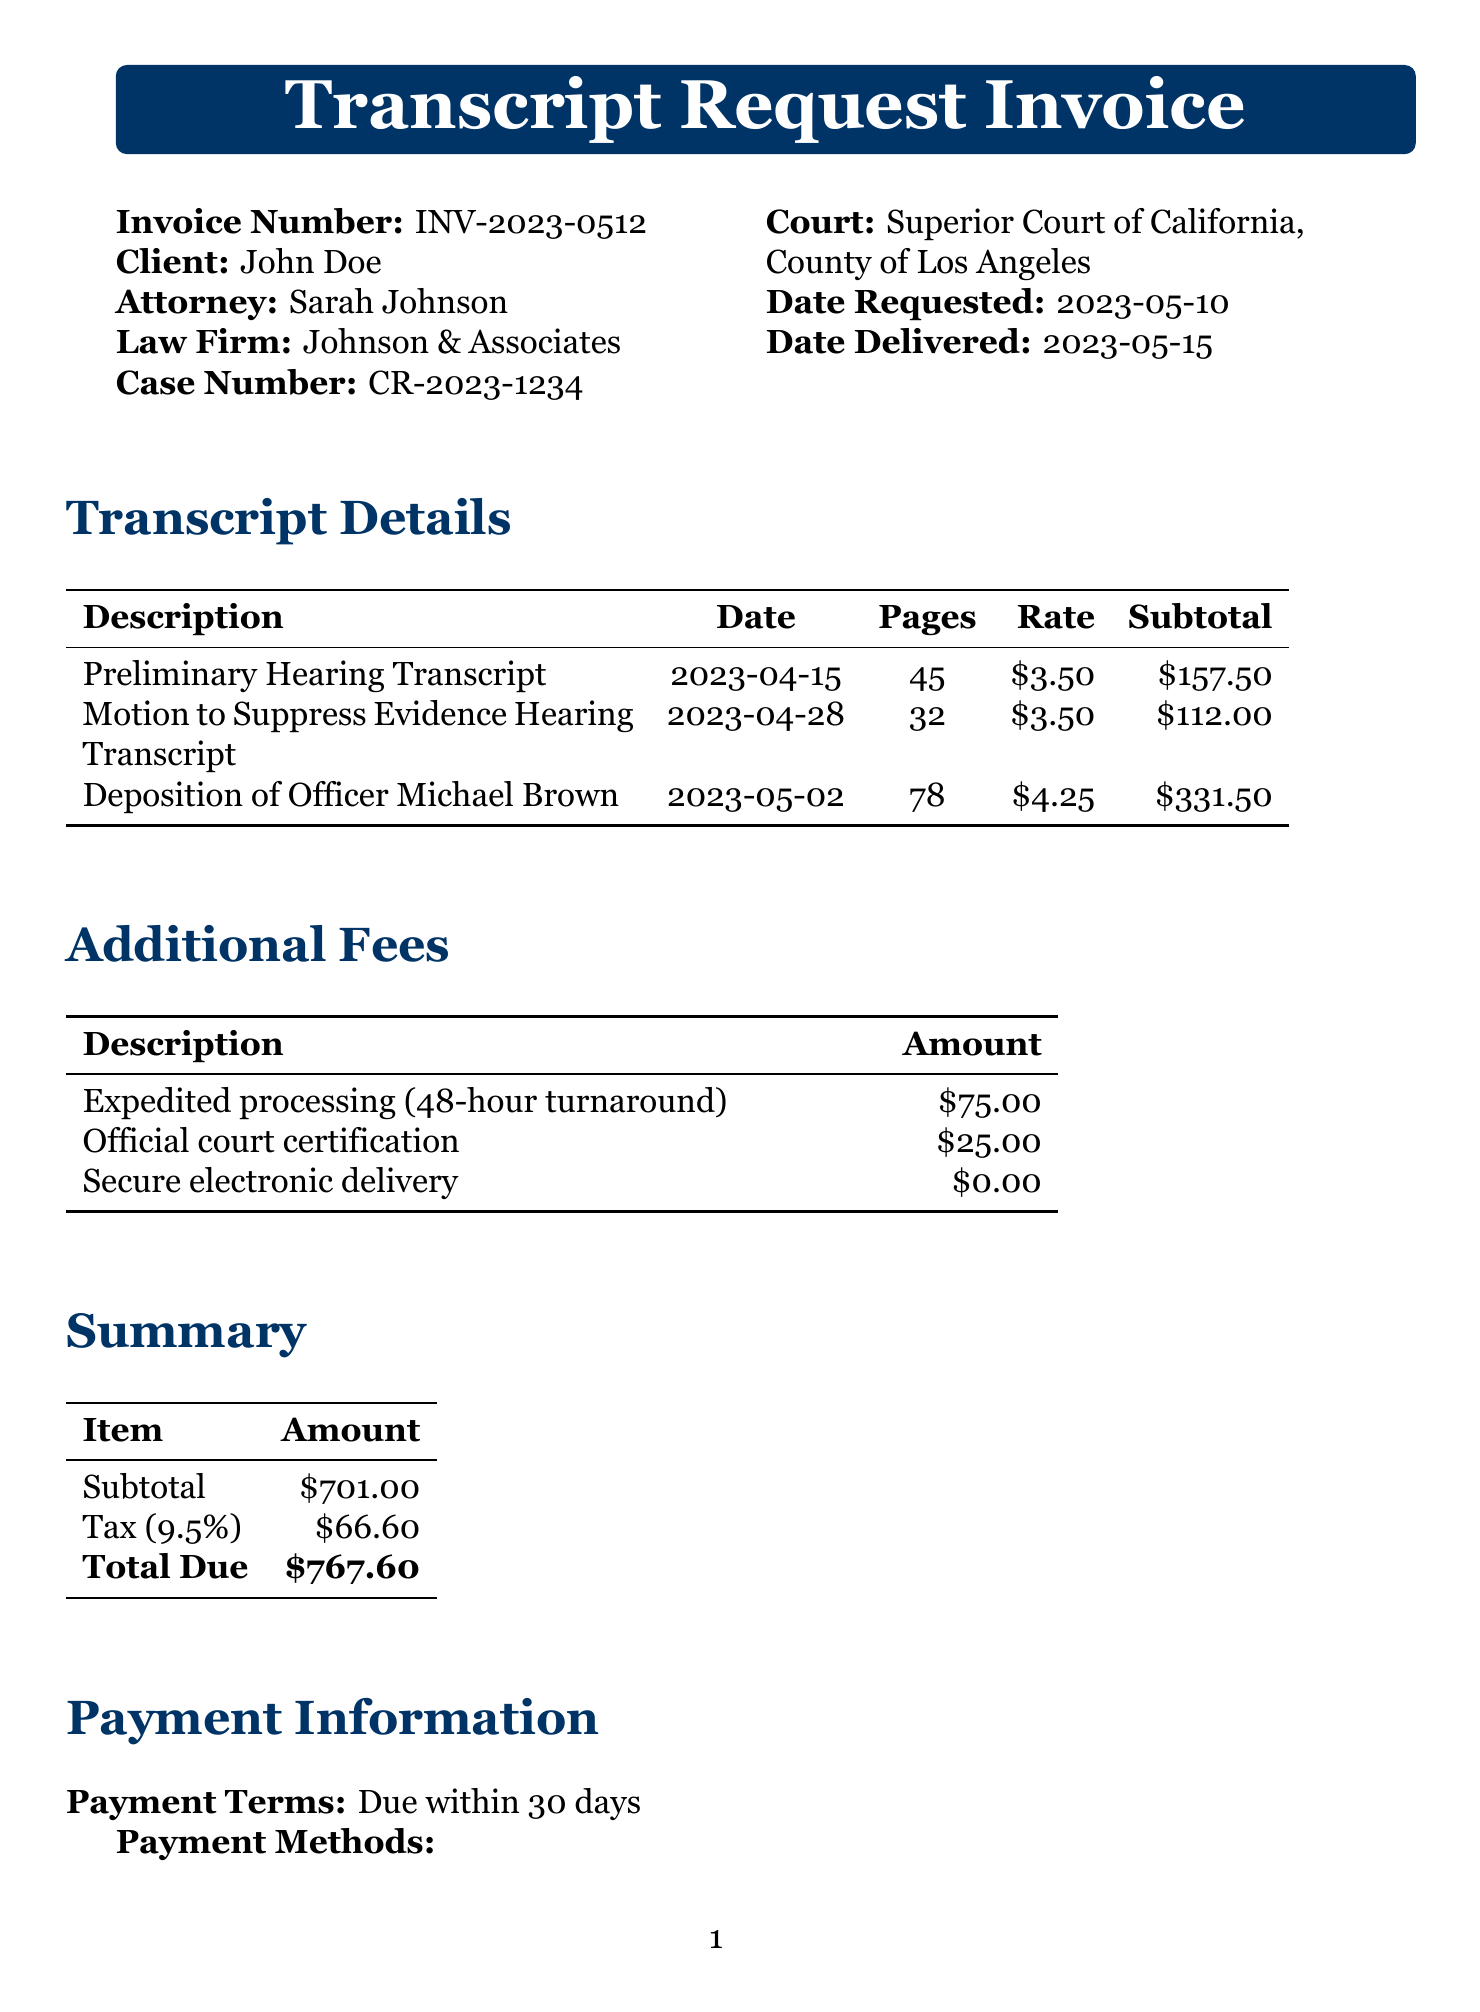What is the invoice number? The invoice number is a unique identifier for this document, listed as "INV-2023-0512".
Answer: INV-2023-0512 Who is the attorney's name? The attorney's name is provided in the document, which is "Sarah Johnson".
Answer: Sarah Johnson What is the total due amount? The total due amount is the final charge that needs to be settled, mentioned as "$767.60".
Answer: $767.60 How many pages are in the deposition of Officer Michael Brown transcript? The number of pages is listed in the transcript details, specifically for the deposition of Officer Michael Brown, which is "78".
Answer: 78 What is the rate per page for the Preliminary Hearing Transcript? The rate per page is indicated in the document, which is "$3.50".
Answer: $3.50 What is the rush fee amount for expedited processing? The rush fee for expedited processing is explicitly stated as "$75.00".
Answer: $75.00 What method of delivery is used for the transcripts? The delivery method for the transcripts is mentioned in the document, which is "Secure electronic delivery".
Answer: Secure electronic delivery How many transcriptions were requested in total? The total number of transcriptions can be counted from the transcript details, which is "3".
Answer: 3 What is the payment term for this invoice? The payment term specifies when payment is due, stated as "Due within 30 days".
Answer: Due within 30 days 